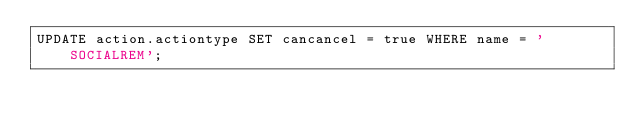Convert code to text. <code><loc_0><loc_0><loc_500><loc_500><_SQL_>UPDATE action.actiontype SET cancancel = true WHERE name = 'SOCIALREM';</code> 